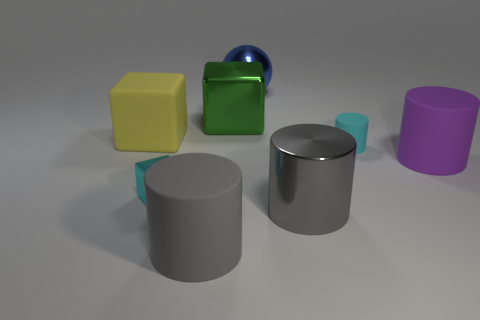Are there an equal number of balls in front of the big gray matte cylinder and large purple things that are in front of the green shiny block?
Offer a very short reply. No. Is the shape of the large purple thing the same as the cyan metallic thing?
Your response must be concise. No. What is the cylinder that is both on the right side of the blue metal sphere and left of the small cyan matte cylinder made of?
Offer a terse response. Metal. What number of gray matte things have the same shape as the big gray metallic object?
Offer a very short reply. 1. There is a gray cylinder on the right side of the big gray cylinder left of the shiny cube that is behind the large purple cylinder; what size is it?
Offer a very short reply. Large. Is the number of gray metal things that are behind the big gray rubber cylinder greater than the number of big yellow spheres?
Give a very brief answer. Yes. Are there any small cyan things?
Your answer should be very brief. Yes. How many red matte spheres have the same size as the green metal object?
Provide a succinct answer. 0. Is the number of big matte objects in front of the cyan rubber cylinder greater than the number of large shiny objects that are right of the large purple object?
Your response must be concise. Yes. There is a yellow block that is the same size as the blue metallic sphere; what is its material?
Your response must be concise. Rubber. 